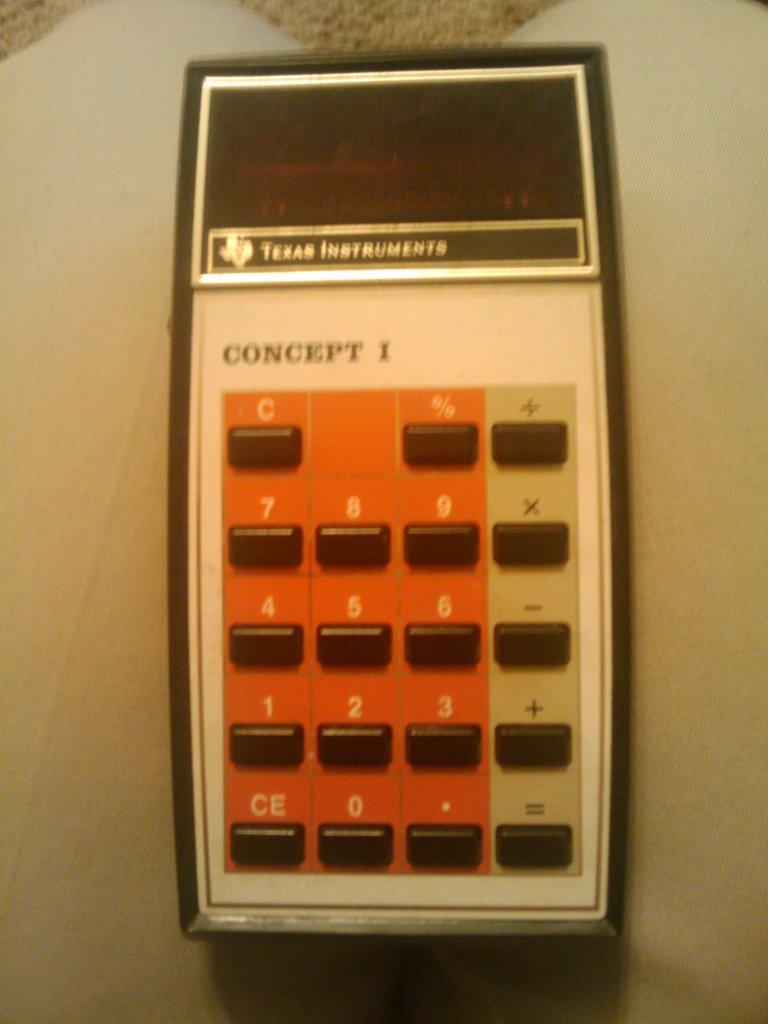<image>
Present a compact description of the photo's key features. A Texas Instruments calculator is named Concept 1. 